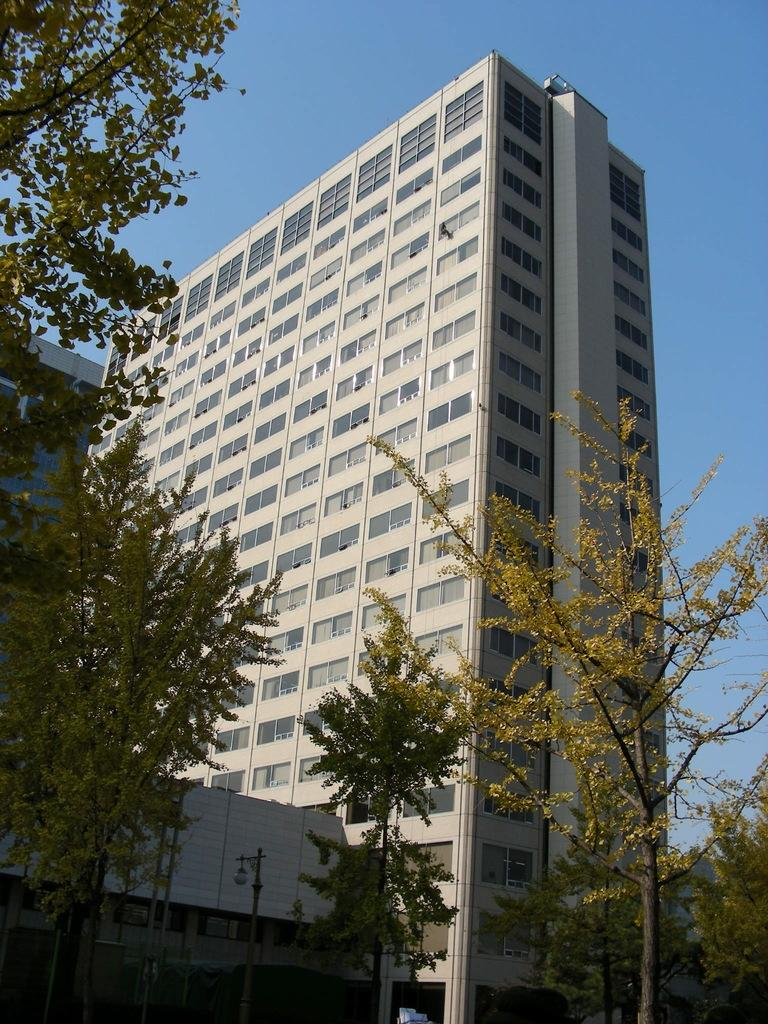What type of structures can be seen in the image? There are buildings in the image. What type of natural elements are present in the image? There are trees in the image. What part of the natural environment is visible in the image? The sky is visible in the image. What type of dress is the government wearing in the image? There is no dress or government present in the image. What type of picture is being taken of the government in the image? There is no picture or government present in the image. 